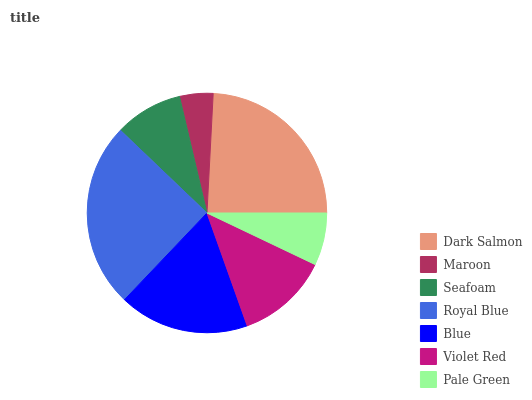Is Maroon the minimum?
Answer yes or no. Yes. Is Royal Blue the maximum?
Answer yes or no. Yes. Is Seafoam the minimum?
Answer yes or no. No. Is Seafoam the maximum?
Answer yes or no. No. Is Seafoam greater than Maroon?
Answer yes or no. Yes. Is Maroon less than Seafoam?
Answer yes or no. Yes. Is Maroon greater than Seafoam?
Answer yes or no. No. Is Seafoam less than Maroon?
Answer yes or no. No. Is Violet Red the high median?
Answer yes or no. Yes. Is Violet Red the low median?
Answer yes or no. Yes. Is Seafoam the high median?
Answer yes or no. No. Is Dark Salmon the low median?
Answer yes or no. No. 